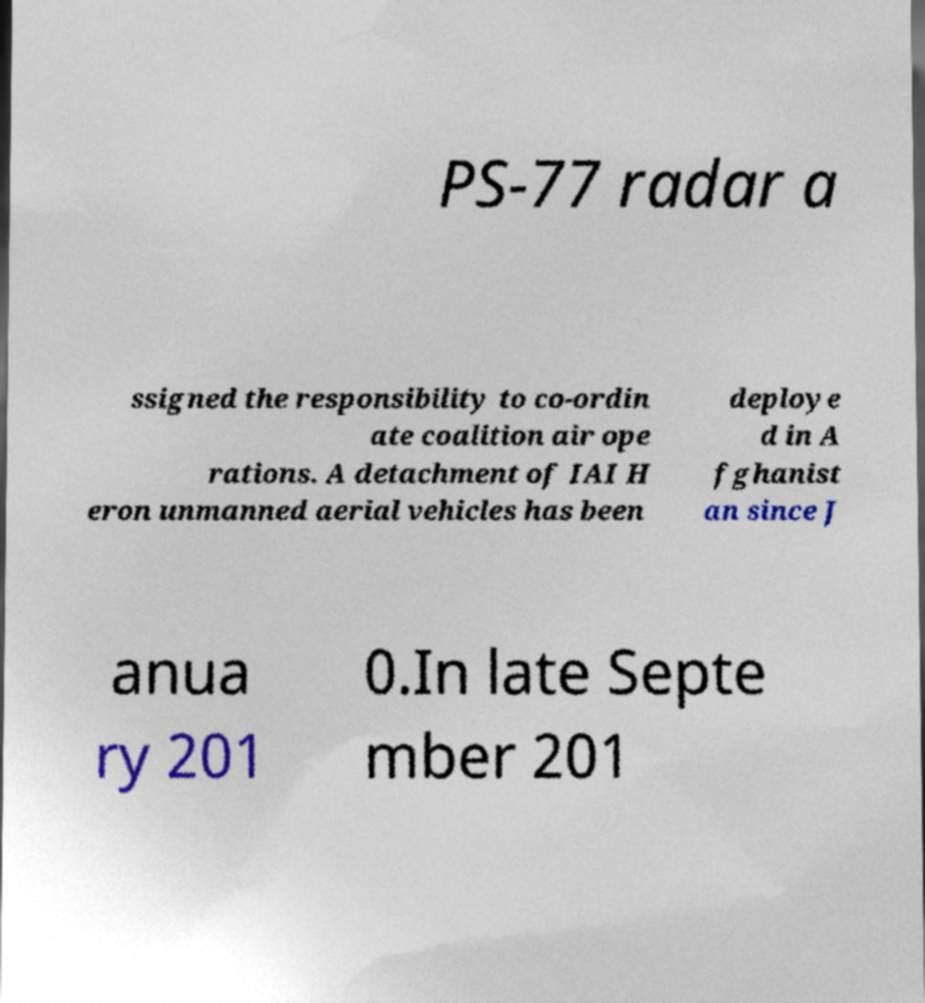What messages or text are displayed in this image? I need them in a readable, typed format. PS-77 radar a ssigned the responsibility to co-ordin ate coalition air ope rations. A detachment of IAI H eron unmanned aerial vehicles has been deploye d in A fghanist an since J anua ry 201 0.In late Septe mber 201 